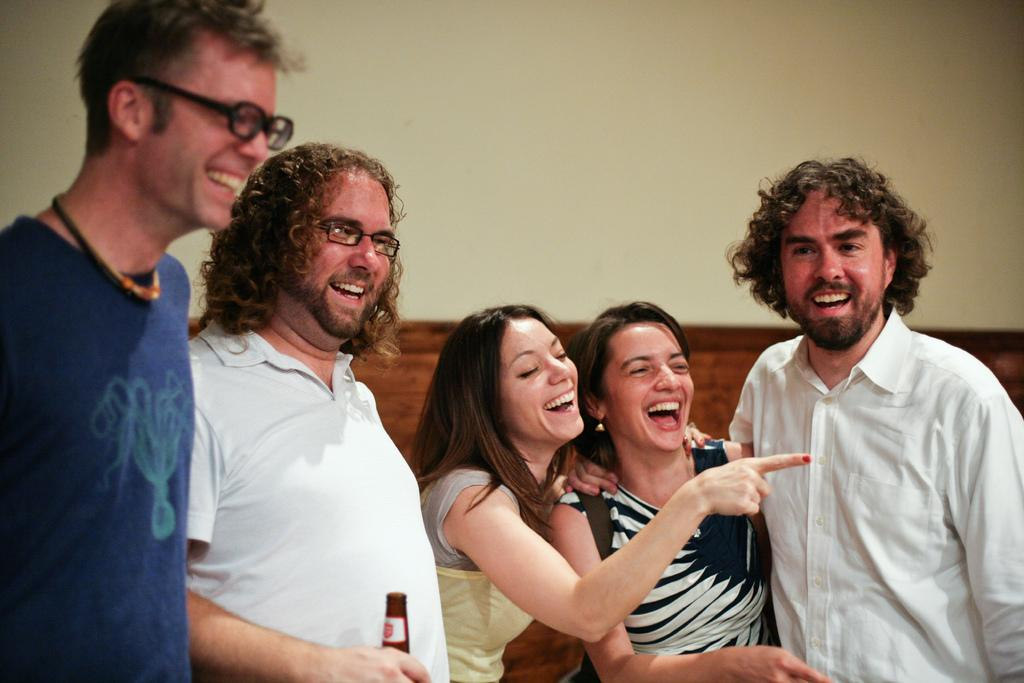How many people are in the image? There are persons in the image, but the exact number is not specified. What is the facial expression of the people in the image? The persons in the image are smiling. Can you describe the man in the center of the image? The man in the center of the image is standing and smiling. What is the man holding in his hand? The man is holding a bottle in his hand. What subject is the man teaching to the crowd in the image? There is no mention of a crowd or teaching in the image; it only features a man standing and smiling while holding a bottle. 